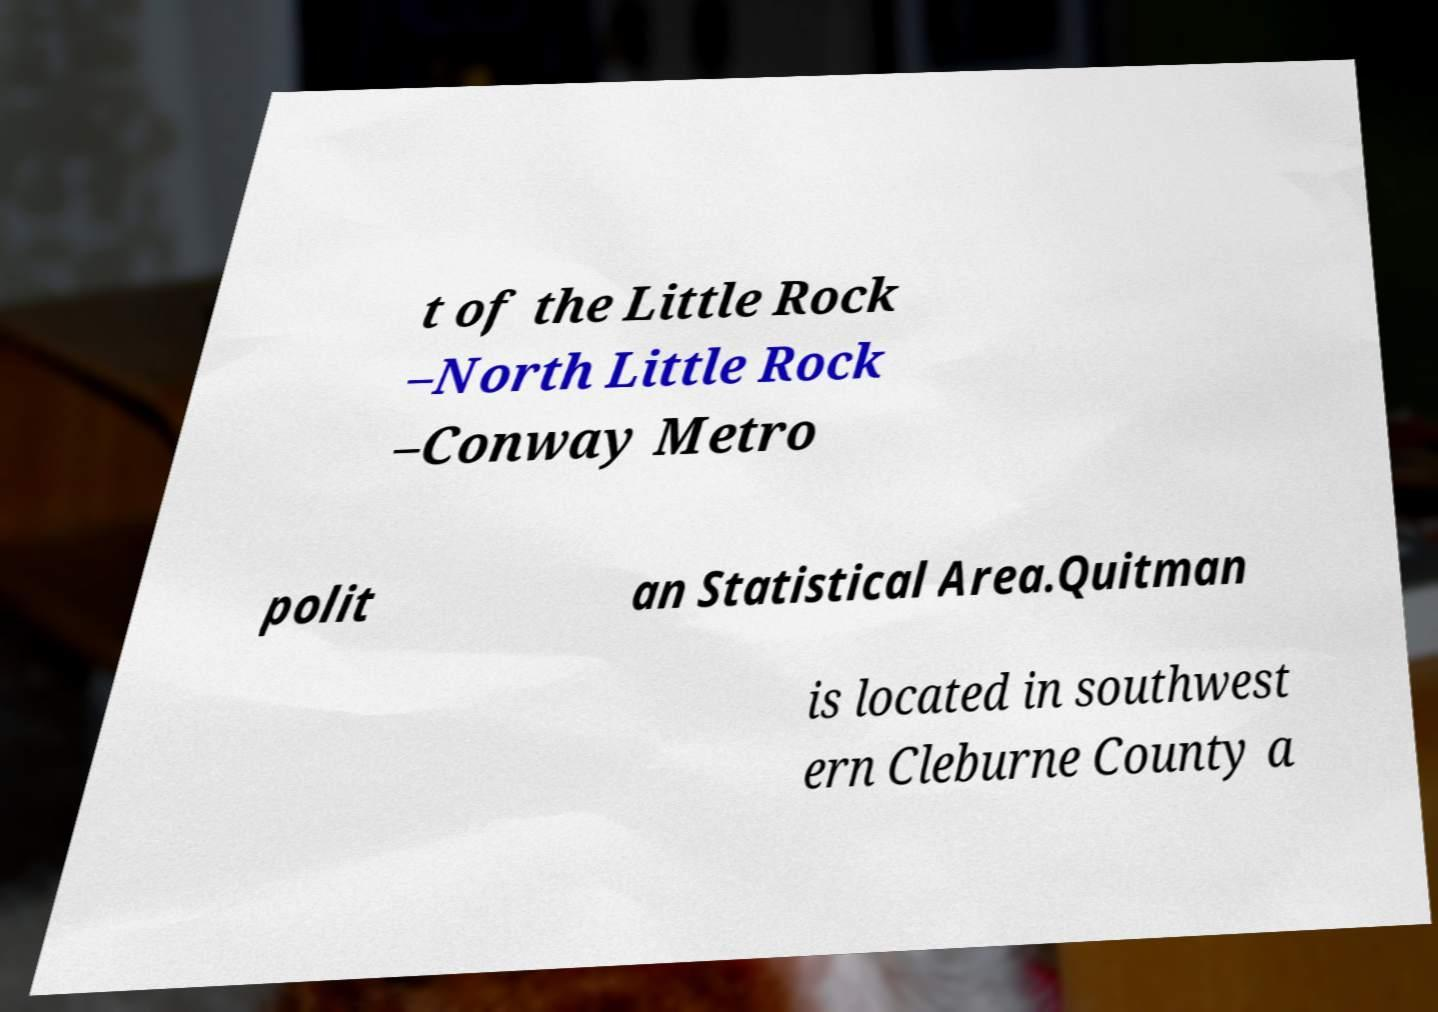For documentation purposes, I need the text within this image transcribed. Could you provide that? t of the Little Rock –North Little Rock –Conway Metro polit an Statistical Area.Quitman is located in southwest ern Cleburne County a 